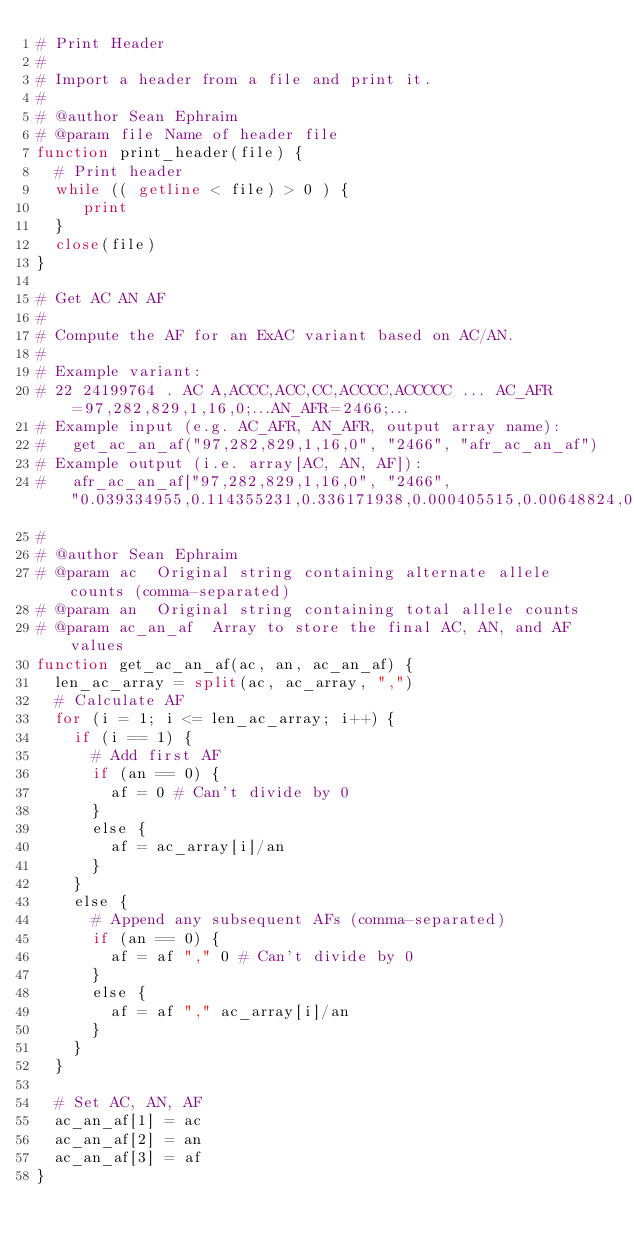<code> <loc_0><loc_0><loc_500><loc_500><_Awk_># Print Header
#
# Import a header from a file and print it.
#
# @author Sean Ephraim
# @param file Name of header file
function print_header(file) {
  # Print header
  while (( getline < file) > 0 ) {
     print
  }
  close(file)
}

# Get AC AN AF
#
# Compute the AF for an ExAC variant based on AC/AN.
#
# Example variant:
# 22 24199764 . AC A,ACCC,ACC,CC,ACCCC,ACCCCC ... AC_AFR=97,282,829,1,16,0;...AN_AFR=2466;...
# Example input (e.g. AC_AFR, AN_AFR, output array name):
#   get_ac_an_af("97,282,829,1,16,0", "2466", "afr_ac_an_af")
# Example output (i.e. array[AC, AN, AF]):
#   afr_ac_an_af["97,282,829,1,16,0", "2466", "0.039334955,0.114355231,0.336171938,0.000405515,0.00648824,0"]
#
# @author Sean Ephraim
# @param ac  Original string containing alternate allele counts (comma-separated)
# @param an  Original string containing total allele counts
# @param ac_an_af  Array to store the final AC, AN, and AF values
function get_ac_an_af(ac, an, ac_an_af) {
  len_ac_array = split(ac, ac_array, ",")
  # Calculate AF
  for (i = 1; i <= len_ac_array; i++) {
    if (i == 1) {
      # Add first AF
      if (an == 0) {
        af = 0 # Can't divide by 0
      }
      else {
        af = ac_array[i]/an
      }
    }
    else {
      # Append any subsequent AFs (comma-separated)
      if (an == 0) {
        af = af "," 0 # Can't divide by 0
      }
      else {
        af = af "," ac_array[i]/an
      }
    }
  }

  # Set AC, AN, AF
  ac_an_af[1] = ac
  ac_an_af[2] = an
  ac_an_af[3] = af
}
</code> 